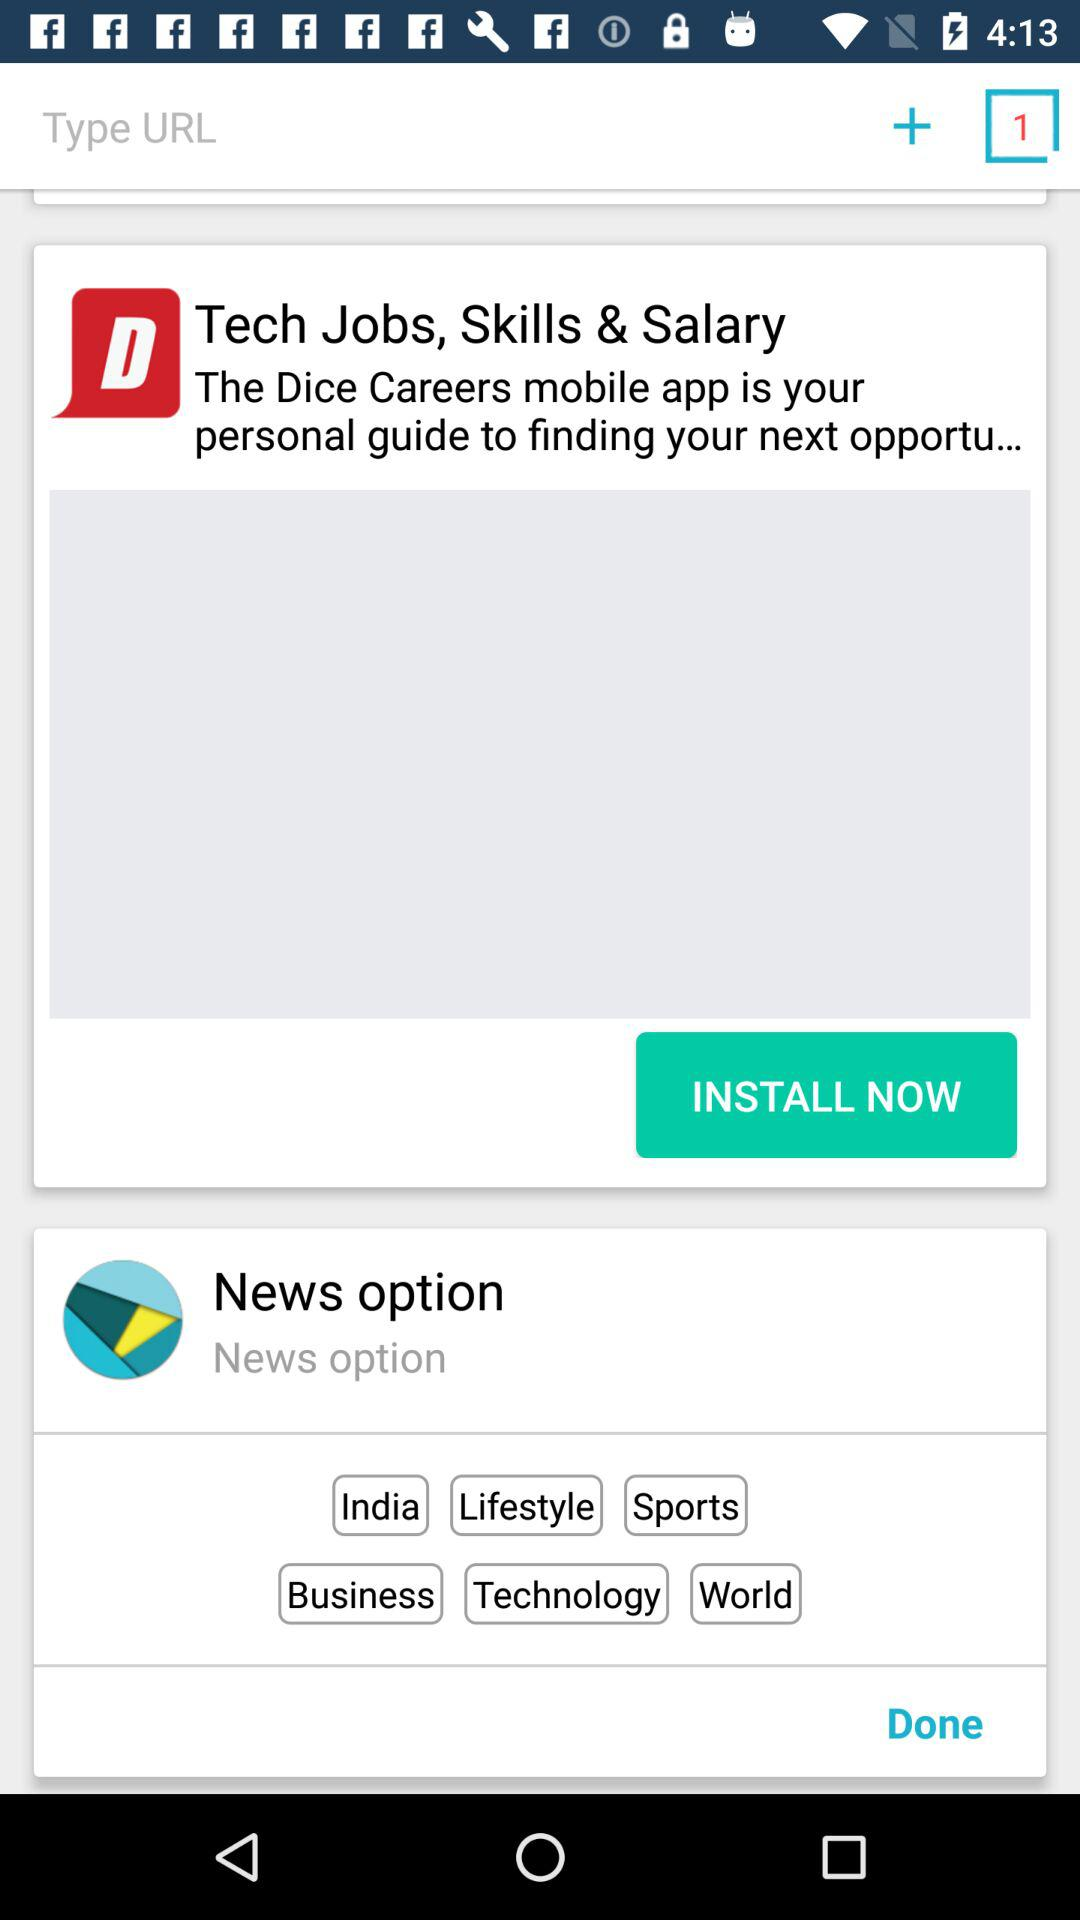What are the news options there? The news options are India, Lifestyle, Sports, Business, Technology and World. 